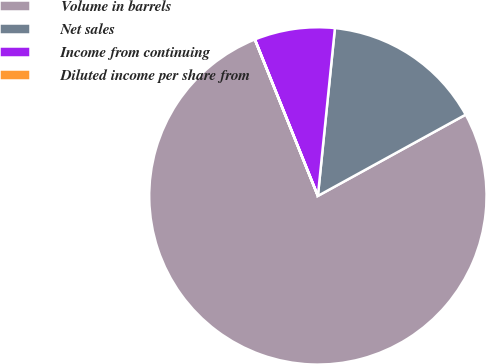Convert chart. <chart><loc_0><loc_0><loc_500><loc_500><pie_chart><fcel>Volume in barrels<fcel>Net sales<fcel>Income from continuing<fcel>Diluted income per share from<nl><fcel>76.91%<fcel>15.39%<fcel>7.7%<fcel>0.01%<nl></chart> 